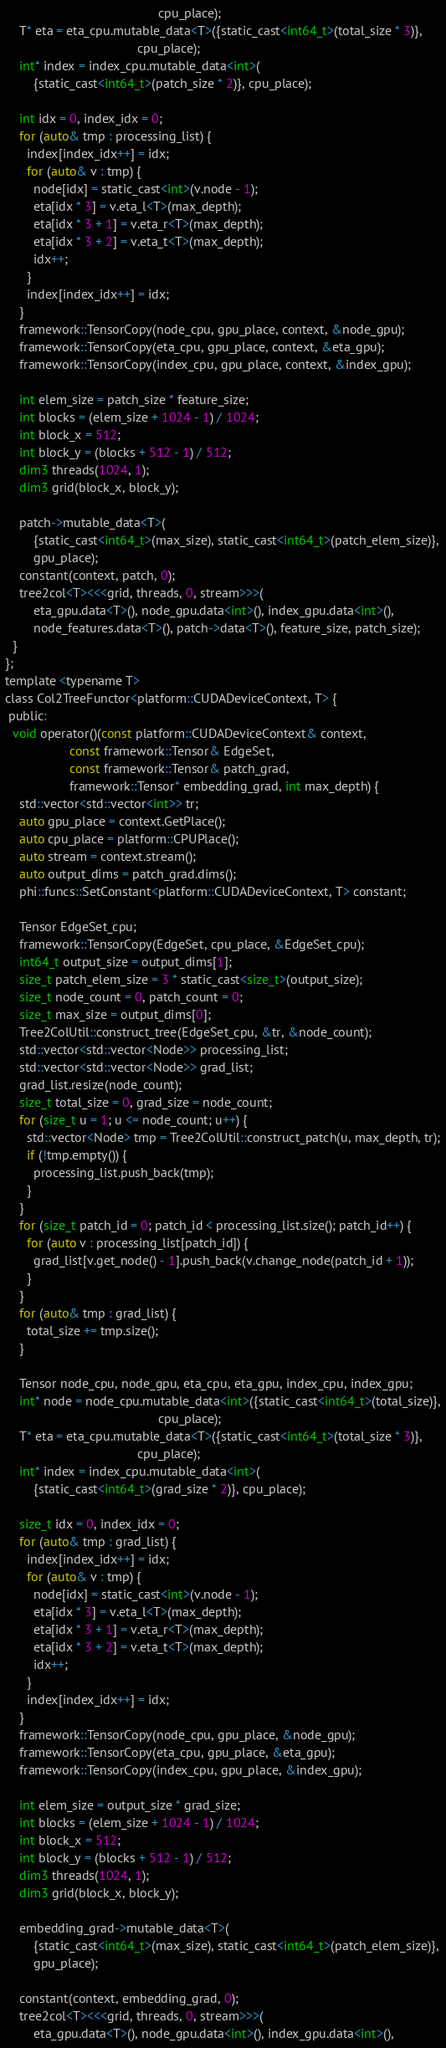<code> <loc_0><loc_0><loc_500><loc_500><_Cuda_>                                           cpu_place);
    T* eta = eta_cpu.mutable_data<T>({static_cast<int64_t>(total_size * 3)},
                                     cpu_place);
    int* index = index_cpu.mutable_data<int>(
        {static_cast<int64_t>(patch_size * 2)}, cpu_place);

    int idx = 0, index_idx = 0;
    for (auto& tmp : processing_list) {
      index[index_idx++] = idx;
      for (auto& v : tmp) {
        node[idx] = static_cast<int>(v.node - 1);
        eta[idx * 3] = v.eta_l<T>(max_depth);
        eta[idx * 3 + 1] = v.eta_r<T>(max_depth);
        eta[idx * 3 + 2] = v.eta_t<T>(max_depth);
        idx++;
      }
      index[index_idx++] = idx;
    }
    framework::TensorCopy(node_cpu, gpu_place, context, &node_gpu);
    framework::TensorCopy(eta_cpu, gpu_place, context, &eta_gpu);
    framework::TensorCopy(index_cpu, gpu_place, context, &index_gpu);

    int elem_size = patch_size * feature_size;
    int blocks = (elem_size + 1024 - 1) / 1024;
    int block_x = 512;
    int block_y = (blocks + 512 - 1) / 512;
    dim3 threads(1024, 1);
    dim3 grid(block_x, block_y);

    patch->mutable_data<T>(
        {static_cast<int64_t>(max_size), static_cast<int64_t>(patch_elem_size)},
        gpu_place);
    constant(context, patch, 0);
    tree2col<T><<<grid, threads, 0, stream>>>(
        eta_gpu.data<T>(), node_gpu.data<int>(), index_gpu.data<int>(),
        node_features.data<T>(), patch->data<T>(), feature_size, patch_size);
  }
};
template <typename T>
class Col2TreeFunctor<platform::CUDADeviceContext, T> {
 public:
  void operator()(const platform::CUDADeviceContext& context,
                  const framework::Tensor& EdgeSet,
                  const framework::Tensor& patch_grad,
                  framework::Tensor* embedding_grad, int max_depth) {
    std::vector<std::vector<int>> tr;
    auto gpu_place = context.GetPlace();
    auto cpu_place = platform::CPUPlace();
    auto stream = context.stream();
    auto output_dims = patch_grad.dims();
    phi::funcs::SetConstant<platform::CUDADeviceContext, T> constant;

    Tensor EdgeSet_cpu;
    framework::TensorCopy(EdgeSet, cpu_place, &EdgeSet_cpu);
    int64_t output_size = output_dims[1];
    size_t patch_elem_size = 3 * static_cast<size_t>(output_size);
    size_t node_count = 0, patch_count = 0;
    size_t max_size = output_dims[0];
    Tree2ColUtil::construct_tree(EdgeSet_cpu, &tr, &node_count);
    std::vector<std::vector<Node>> processing_list;
    std::vector<std::vector<Node>> grad_list;
    grad_list.resize(node_count);
    size_t total_size = 0, grad_size = node_count;
    for (size_t u = 1; u <= node_count; u++) {
      std::vector<Node> tmp = Tree2ColUtil::construct_patch(u, max_depth, tr);
      if (!tmp.empty()) {
        processing_list.push_back(tmp);
      }
    }
    for (size_t patch_id = 0; patch_id < processing_list.size(); patch_id++) {
      for (auto v : processing_list[patch_id]) {
        grad_list[v.get_node() - 1].push_back(v.change_node(patch_id + 1));
      }
    }
    for (auto& tmp : grad_list) {
      total_size += tmp.size();
    }

    Tensor node_cpu, node_gpu, eta_cpu, eta_gpu, index_cpu, index_gpu;
    int* node = node_cpu.mutable_data<int>({static_cast<int64_t>(total_size)},
                                           cpu_place);
    T* eta = eta_cpu.mutable_data<T>({static_cast<int64_t>(total_size * 3)},
                                     cpu_place);
    int* index = index_cpu.mutable_data<int>(
        {static_cast<int64_t>(grad_size * 2)}, cpu_place);

    size_t idx = 0, index_idx = 0;
    for (auto& tmp : grad_list) {
      index[index_idx++] = idx;
      for (auto& v : tmp) {
        node[idx] = static_cast<int>(v.node - 1);
        eta[idx * 3] = v.eta_l<T>(max_depth);
        eta[idx * 3 + 1] = v.eta_r<T>(max_depth);
        eta[idx * 3 + 2] = v.eta_t<T>(max_depth);
        idx++;
      }
      index[index_idx++] = idx;
    }
    framework::TensorCopy(node_cpu, gpu_place, &node_gpu);
    framework::TensorCopy(eta_cpu, gpu_place, &eta_gpu);
    framework::TensorCopy(index_cpu, gpu_place, &index_gpu);

    int elem_size = output_size * grad_size;
    int blocks = (elem_size + 1024 - 1) / 1024;
    int block_x = 512;
    int block_y = (blocks + 512 - 1) / 512;
    dim3 threads(1024, 1);
    dim3 grid(block_x, block_y);

    embedding_grad->mutable_data<T>(
        {static_cast<int64_t>(max_size), static_cast<int64_t>(patch_elem_size)},
        gpu_place);

    constant(context, embedding_grad, 0);
    tree2col<T><<<grid, threads, 0, stream>>>(
        eta_gpu.data<T>(), node_gpu.data<int>(), index_gpu.data<int>(),</code> 